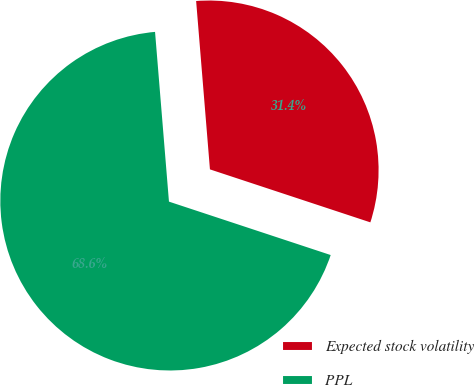Convert chart to OTSL. <chart><loc_0><loc_0><loc_500><loc_500><pie_chart><fcel>Expected stock volatility<fcel>PPL<nl><fcel>31.38%<fcel>68.62%<nl></chart> 